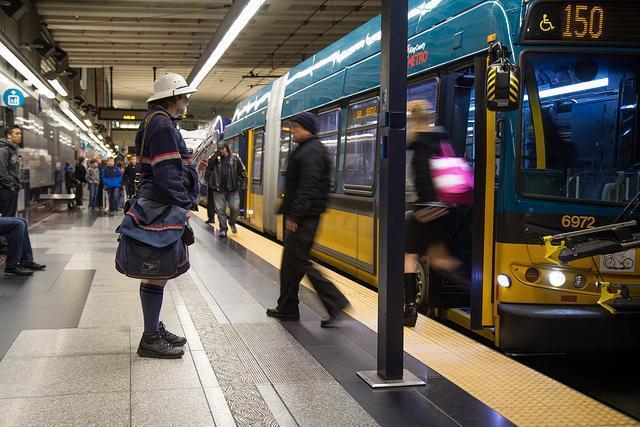How many people can be seen?
Give a very brief answer. 4. 